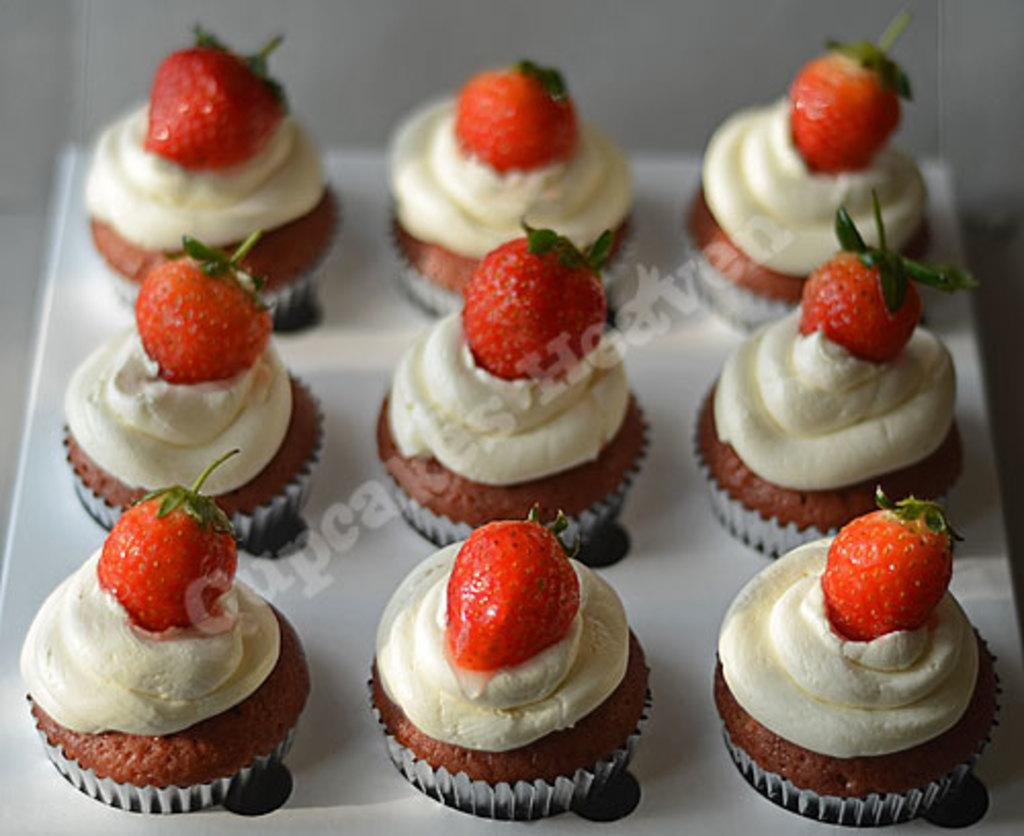What type of dessert can be seen in the image? There are cupcakes in the image. What topping is featured on the cupcakes? The cupcakes have strawberries on them. Where are the cupcakes placed in the image? The cupcakes are on a platform. What type of drum is being played in the image? There is no drum present in the image; it features cupcakes with strawberries on them. What educational institution is depicted in the image? There is no educational institution present in the image; it features cupcakes with strawberries on them. 